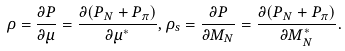Convert formula to latex. <formula><loc_0><loc_0><loc_500><loc_500>\rho = \frac { \partial P } { \partial \mu } = \frac { \partial ( P _ { N } + P _ { \pi } ) } { \partial \mu ^ { * } } , \rho _ { s } = \frac { \partial P } { \partial M _ { N } } = \frac { \partial ( P _ { N } + P _ { \pi } ) } { \partial M _ { N } ^ { * } } .</formula> 